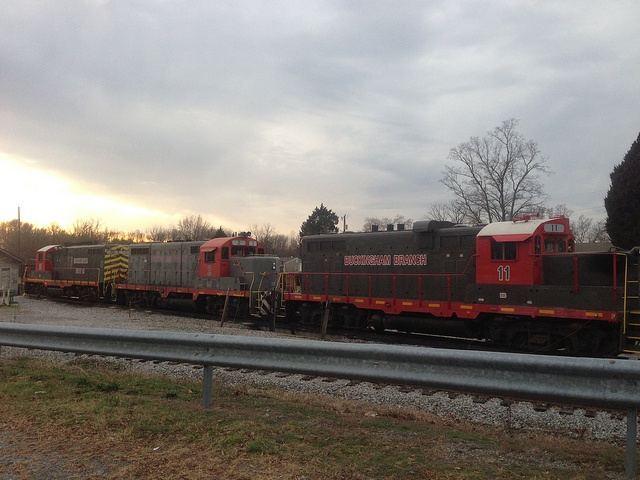Describe the objects in this image and their specific colors. I can see a train in lightgray, black, maroon, and gray tones in this image. 